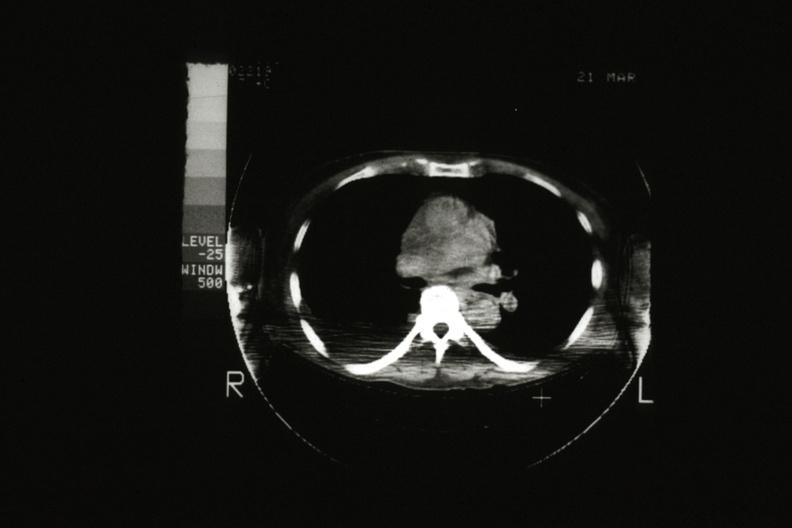does this person scan showing tumor mass invading superior vena ca?
Answer the question using a single word or phrase. No 